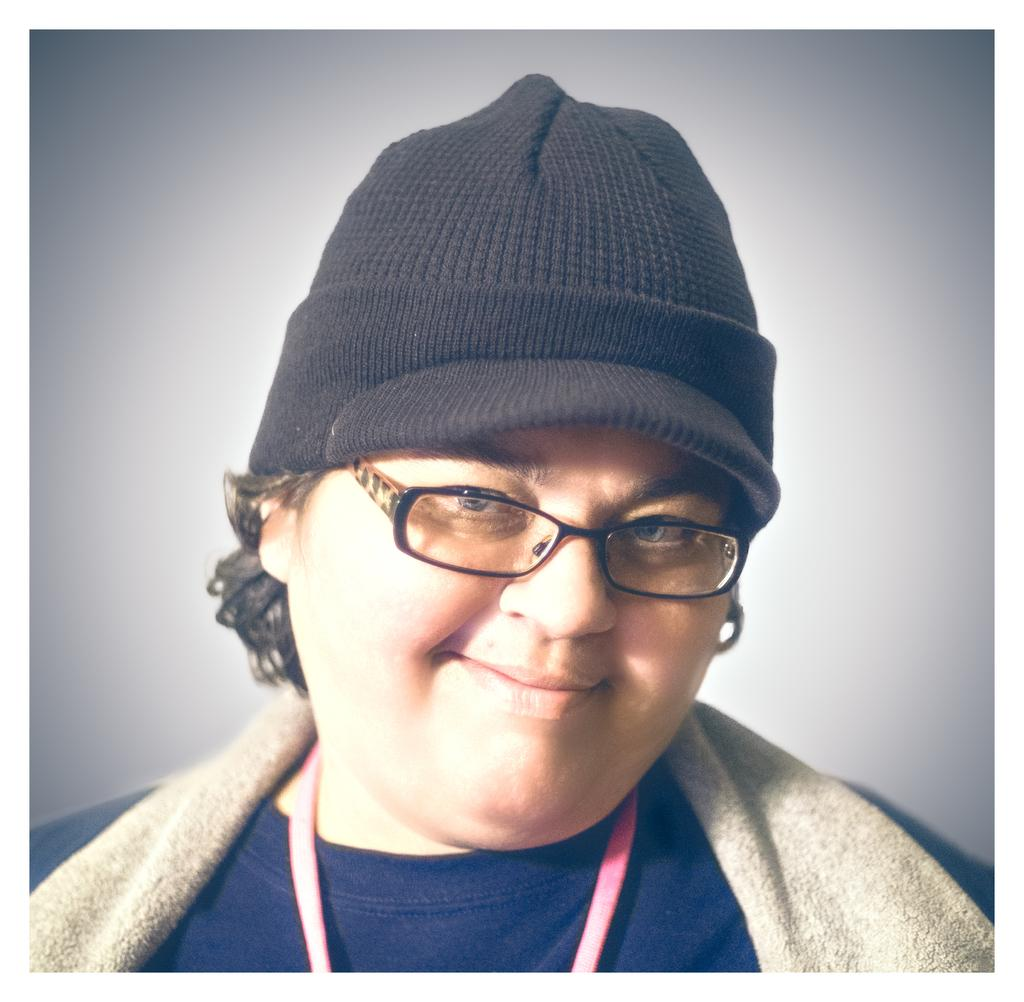What is the main subject of the image? There is a person in the image. What is the person wearing? The person is wearing a blue t-shirt. What is the person's facial expression? The person is smiling. What can be seen in the background of the image? There is a wall visible in the background of the image. What type of toys does the person own in the image? There is no mention of toys in the image, so it cannot be determined if the person owns any. 